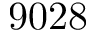<formula> <loc_0><loc_0><loc_500><loc_500>9 0 2 8</formula> 